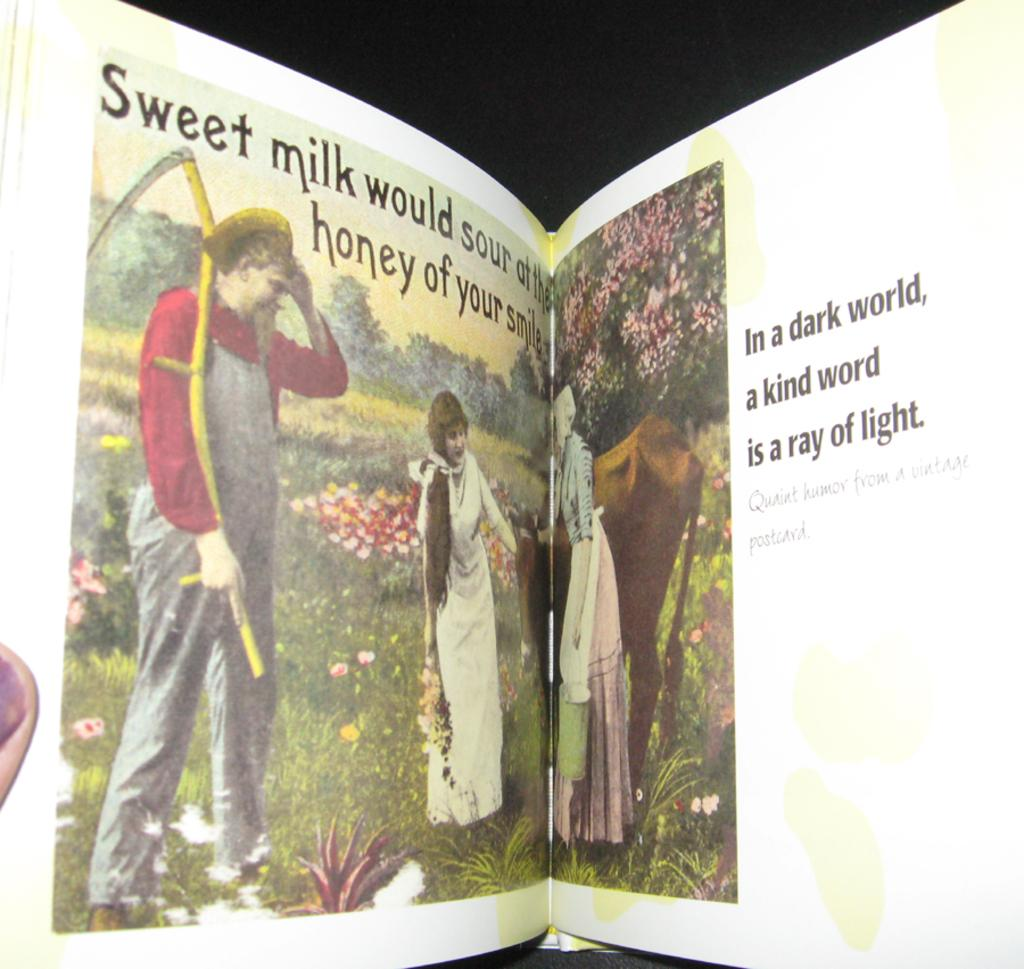Provide a one-sentence caption for the provided image. An opened book with the words sweet milk on the left page. 